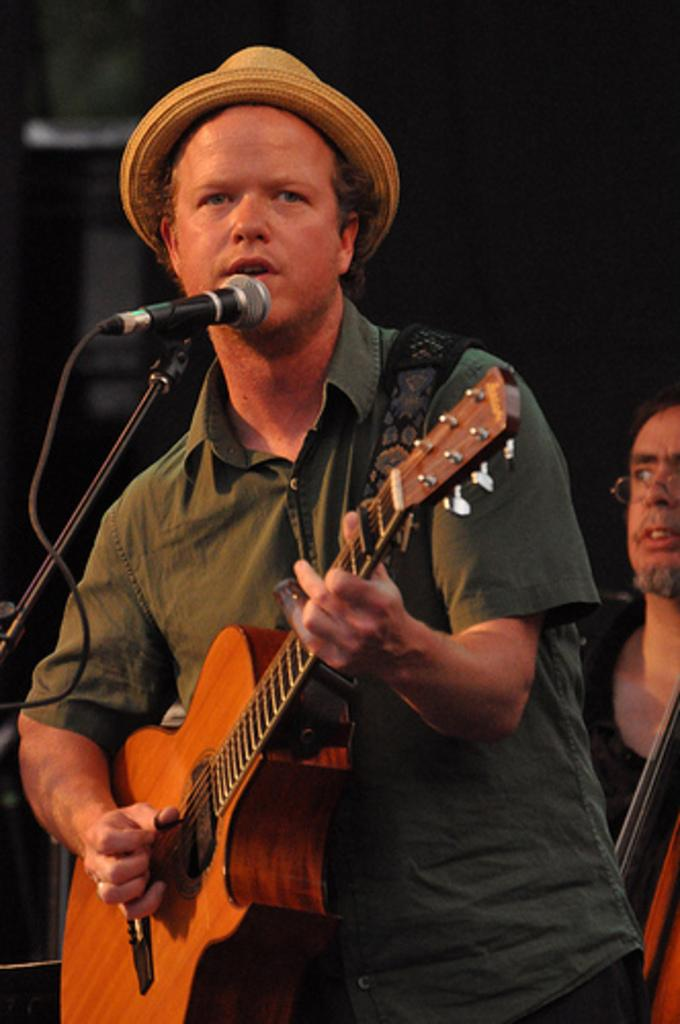What is the main subject of the image? There is a person standing in the center of the image. What is the person in the center doing? The person is holding a guitar in his hand and singing on a microphone. Can you describe the second person in the image? The second person is in the background of the image, on the right side. What month is it in the image? The image does not provide any information about the month or time of year. Can you tell me how many friends the person in the center has in the image? The image does not provide any information about friends or relationships between the people depicted. 